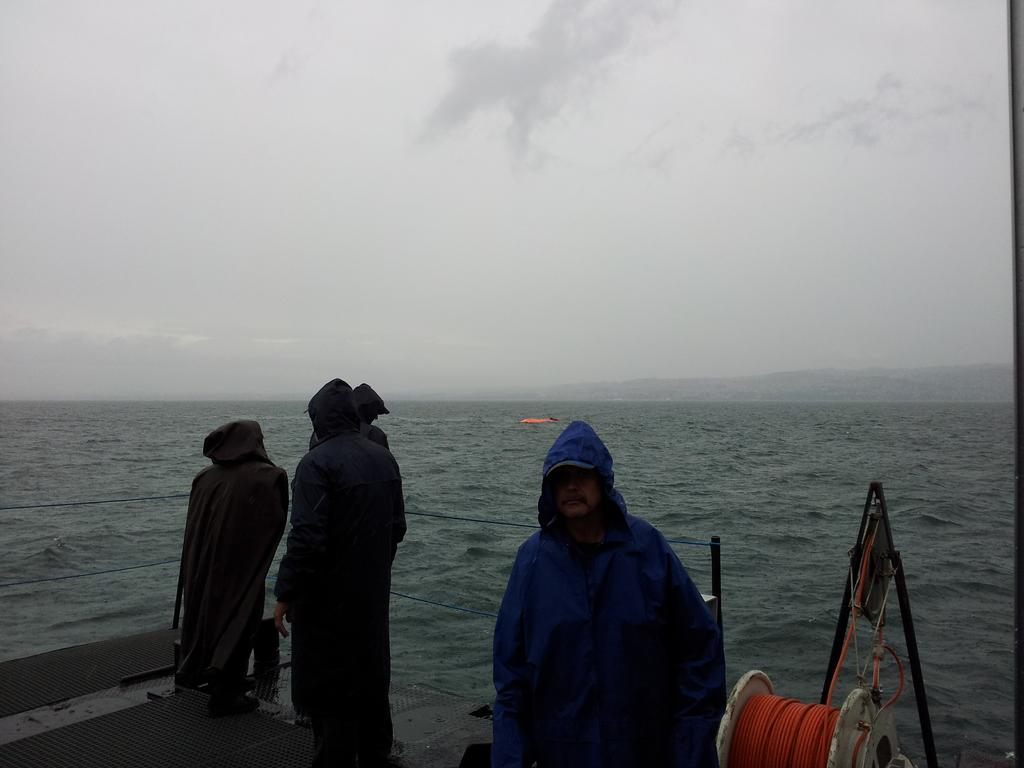What can be seen in the sky in the image? The sky with clouds is visible in the image. What type of natural feature is present in the image? There is a sea in the image. What are the people in the image doing? There are persons standing on the surface in the image. What objects are present in the image that might be used for support or attachment? Ropes and poles are visible in the image. What is a specific object in the image that involves a rope? A spinning wheel winded with a rope is in the image. How many quarters are being used to play volleyball in the image? There is no volleyball or quarters present in the image. What is the attempt being made by the persons in the image? The image does not depict any specific attempt or action being made by the persons; they are simply standing on the surface. 